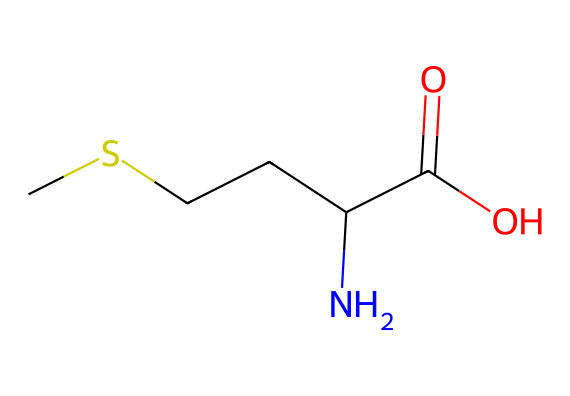What is the molecular formula of this compound? The SMILES representation indicates the atoms present: it contains one sulfur, three carbon, seven hydrogen, one nitrogen, and two oxygen atoms. Therefore, the molecular formula is deduced as C5H11NO2S.
Answer: C5H11NO2S How many chiral centers does methionine have? By analyzing the SMILES structure, we identify that there is one carbon that is attached to four different substituents: a carboxyl group, an amine, a side chain (ethanethiol), and a hydrogen atom. This indicates the presence of one chiral center.
Answer: one What is the functional group present in methionine? The structure includes a carboxylic acid functional group (-COOH) and an amine group (-NH2), which are key functional groups for amino acids. Thus, methionine contains both.
Answer: carboxylic acid What type of organosulfur compound is methionine classified as? Given the presence of sulfur in the structure and its classification as an amino acid, methionine is classified as a sulfur-containing amino acid.
Answer: sulfur-containing amino acid How many heteroatoms does methionine have? The structure includes one nitrogen and one sulfur atom, giving a total of two heteroatoms, which are non-carbon atoms in an organic compound.
Answer: two What distinguishes methionine as an essential amino acid? Methionine is classified as essential because it cannot be synthesized by the human body and must be obtained from dietary sources. This classification is inherent to its structure and biological role.
Answer: dietary source 